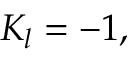<formula> <loc_0><loc_0><loc_500><loc_500>K _ { l } = - 1 ,</formula> 